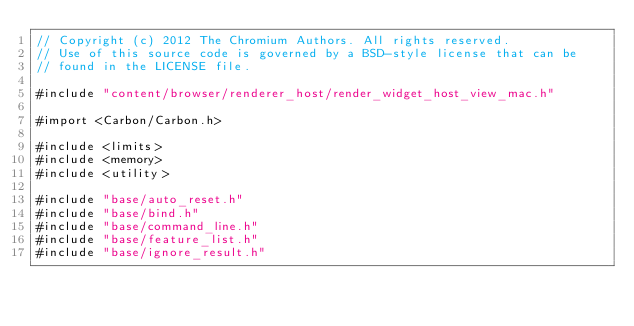<code> <loc_0><loc_0><loc_500><loc_500><_ObjectiveC_>// Copyright (c) 2012 The Chromium Authors. All rights reserved.
// Use of this source code is governed by a BSD-style license that can be
// found in the LICENSE file.

#include "content/browser/renderer_host/render_widget_host_view_mac.h"

#import <Carbon/Carbon.h>

#include <limits>
#include <memory>
#include <utility>

#include "base/auto_reset.h"
#include "base/bind.h"
#include "base/command_line.h"
#include "base/feature_list.h"
#include "base/ignore_result.h"</code> 